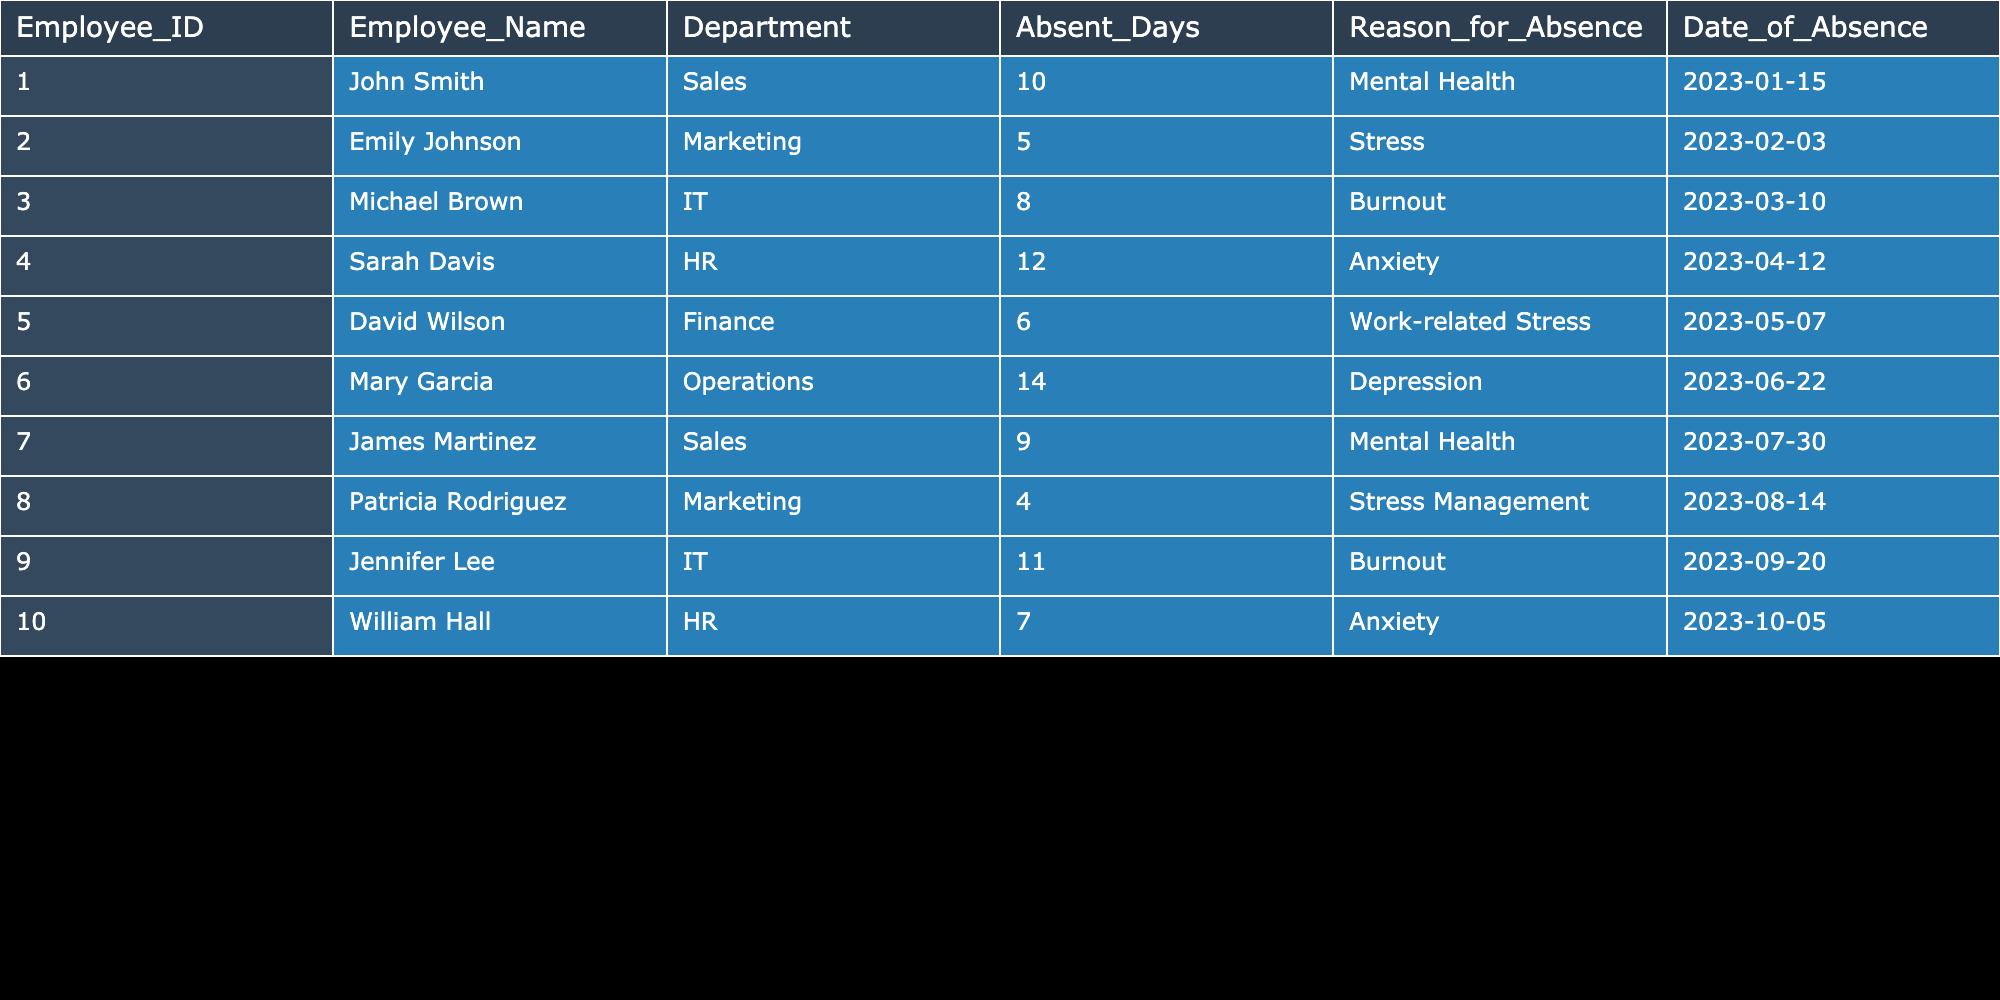What is the total number of absent days among all employees? To find the total absent days, add the absent days of all employees: 10 (John Smith) + 5 (Emily Johnson) + 8 (Michael Brown) + 12 (Sarah Davis) + 6 (David Wilson) + 14 (Mary Garcia) + 9 (James Martinez) + 4 (Patricia Rodriguez) + 11 (Jennifer Lee) + 7 (William Hall) =  10 + 5 + 8 + 12 + 6 + 14 + 9 + 4 + 11 + 7 =  86
Answer: 86 Which employee had the highest number of absent days? Examining the absent days column, compare the values: Mary Garcia has 14 absent days, which is more than any other employee.
Answer: Mary Garcia Did any employees take leave for work-related stress? The records show that David Wilson had 6 absent days for work-related stress. Therefore, the answer is true.
Answer: Yes What is the average number of absent days per employee? There are 10 employees with a total of 86 absent days. To find the average, divide 86 by 10 (total employees): 86/10 = 8.6 absent days per employee.
Answer: 8.6 How many employees reported mental health issues as their reason for absence? From the table, John Smith and James Martinez both cited mental health as their reason for absence. Therefore, there are 2 employees.
Answer: 2 Which department had the most total absent days? Summing by department: Sales (10 + 9 = 19), Marketing (5 + 4 = 9), IT (8 + 11 = 19), HR (12 + 7 = 19), Finance (6 = 6), Operations (14 = 14). Sales, IT, HR have the highest total absent days (19), tied.
Answer: Sales, IT, HR What was the reason for Emily Johnson's absence? Looking at Emily Johnson's row in the table, the reason for her absence is Stress.
Answer: Stress Was there any employee who was absent for anxiety more than once? Checking the table, Sarah Davis and William Hall are listed once each for anxiety, meaning no employees reported anxiety more than once.
Answer: No If we combine the absent days due to Mental Health and Stress, what is the total? Summing the absent days for Mental Health (10 + 9 = 19) and Stress (5 + 4 = 9), we get 19 + 9 = 28 absent days due to these reasons combined.
Answer: 28 